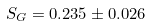Convert formula to latex. <formula><loc_0><loc_0><loc_500><loc_500>S _ { G } = 0 . 2 3 5 \pm 0 . 0 2 6</formula> 